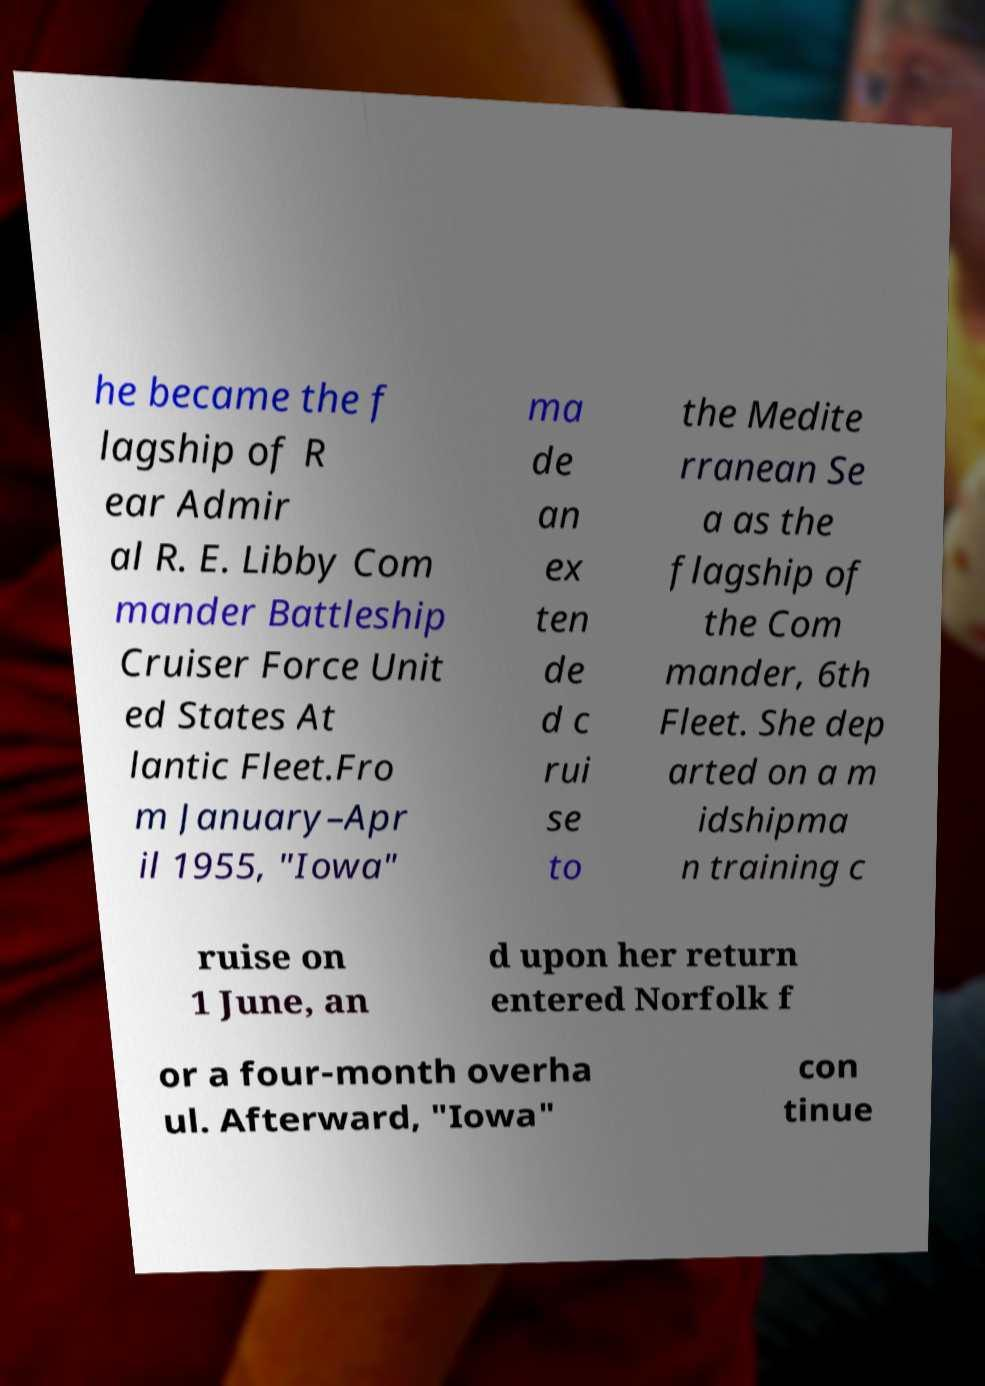Can you read and provide the text displayed in the image?This photo seems to have some interesting text. Can you extract and type it out for me? he became the f lagship of R ear Admir al R. E. Libby Com mander Battleship Cruiser Force Unit ed States At lantic Fleet.Fro m January–Apr il 1955, "Iowa" ma de an ex ten de d c rui se to the Medite rranean Se a as the flagship of the Com mander, 6th Fleet. She dep arted on a m idshipma n training c ruise on 1 June, an d upon her return entered Norfolk f or a four-month overha ul. Afterward, "Iowa" con tinue 